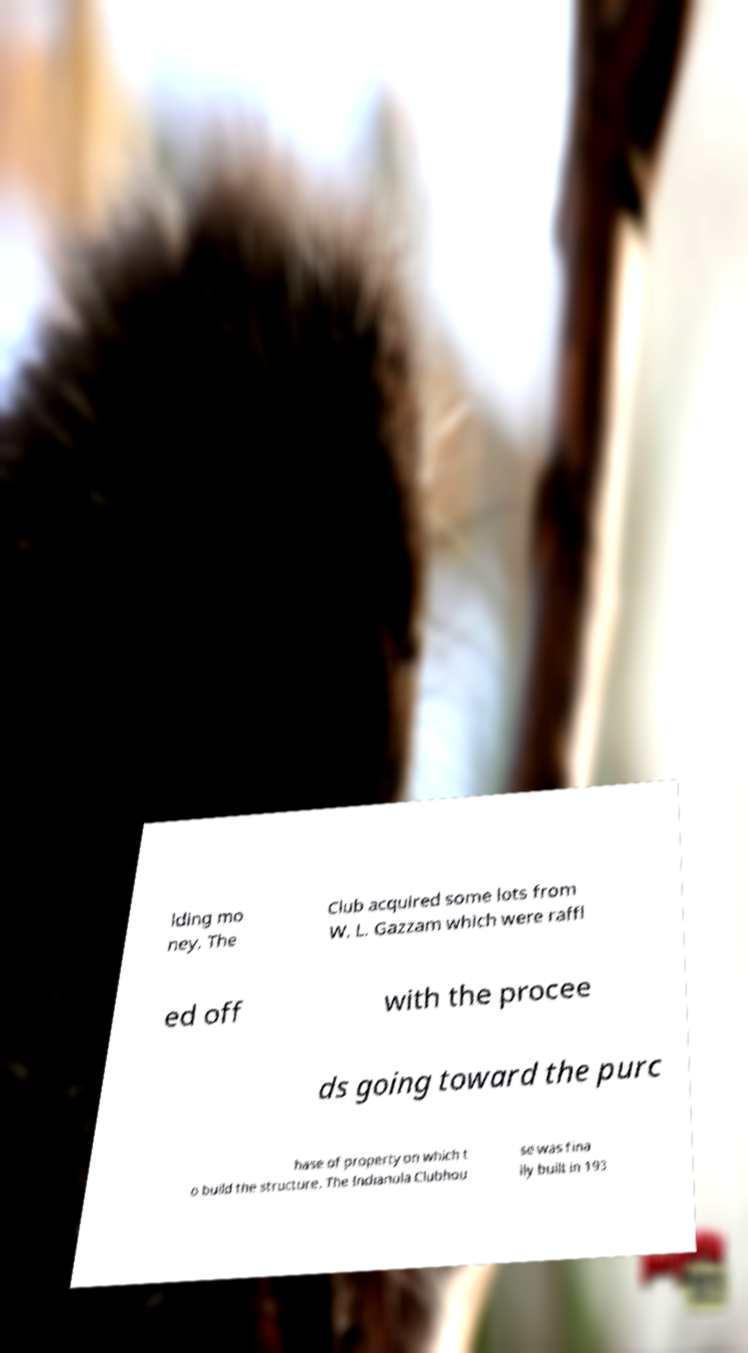Please read and relay the text visible in this image. What does it say? lding mo ney. The Club acquired some lots from W. L. Gazzam which were raffl ed off with the procee ds going toward the purc hase of property on which t o build the structure. The Indianola Clubhou se was fina lly built in 193 